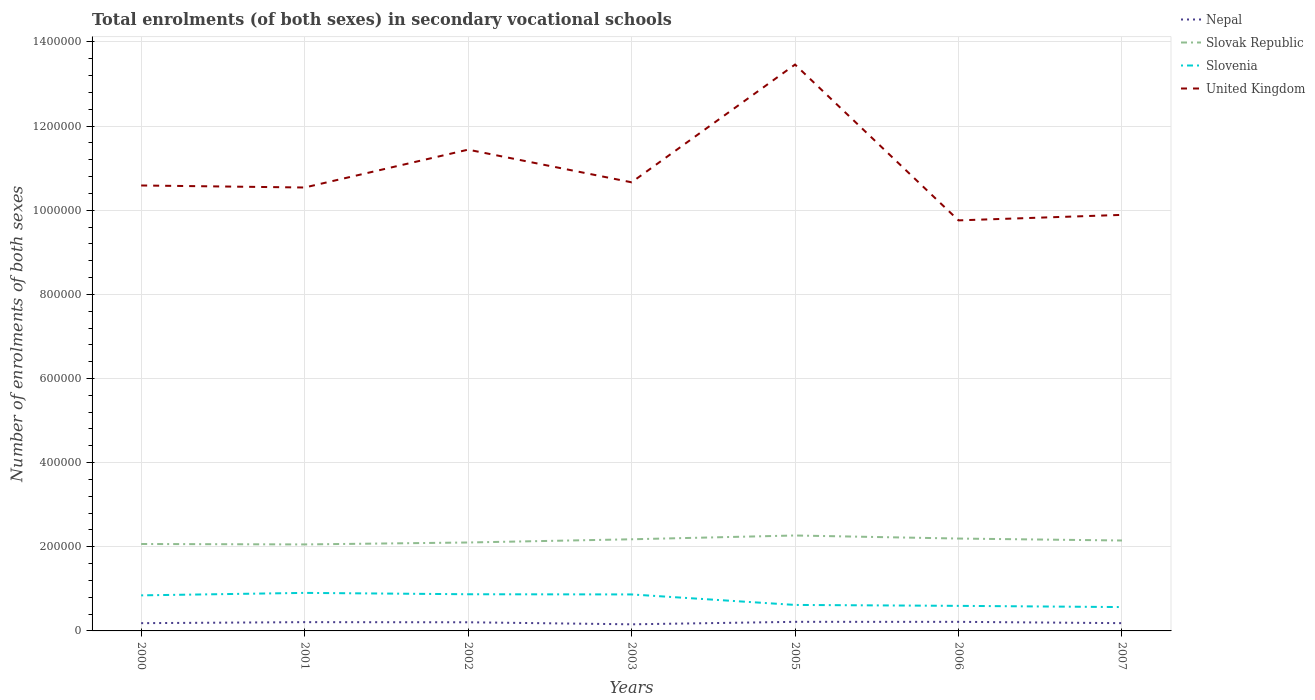How many different coloured lines are there?
Provide a succinct answer. 4. Across all years, what is the maximum number of enrolments in secondary schools in Slovenia?
Provide a short and direct response. 5.67e+04. In which year was the number of enrolments in secondary schools in Slovenia maximum?
Give a very brief answer. 2007. What is the total number of enrolments in secondary schools in Slovak Republic in the graph?
Offer a very short reply. -1.40e+04. What is the difference between the highest and the second highest number of enrolments in secondary schools in Slovenia?
Keep it short and to the point. 3.37e+04. What is the difference between the highest and the lowest number of enrolments in secondary schools in United Kingdom?
Your response must be concise. 2. Is the number of enrolments in secondary schools in United Kingdom strictly greater than the number of enrolments in secondary schools in Slovenia over the years?
Provide a short and direct response. No. How many lines are there?
Provide a succinct answer. 4. How many years are there in the graph?
Provide a succinct answer. 7. Does the graph contain any zero values?
Ensure brevity in your answer.  No. Does the graph contain grids?
Your response must be concise. Yes. Where does the legend appear in the graph?
Give a very brief answer. Top right. How many legend labels are there?
Offer a terse response. 4. What is the title of the graph?
Your answer should be very brief. Total enrolments (of both sexes) in secondary vocational schools. What is the label or title of the Y-axis?
Your answer should be compact. Number of enrolments of both sexes. What is the Number of enrolments of both sexes of Nepal in 2000?
Ensure brevity in your answer.  1.85e+04. What is the Number of enrolments of both sexes in Slovak Republic in 2000?
Give a very brief answer. 2.07e+05. What is the Number of enrolments of both sexes of Slovenia in 2000?
Offer a terse response. 8.45e+04. What is the Number of enrolments of both sexes of United Kingdom in 2000?
Your response must be concise. 1.06e+06. What is the Number of enrolments of both sexes in Nepal in 2001?
Make the answer very short. 2.09e+04. What is the Number of enrolments of both sexes of Slovak Republic in 2001?
Provide a short and direct response. 2.06e+05. What is the Number of enrolments of both sexes of Slovenia in 2001?
Your answer should be very brief. 9.04e+04. What is the Number of enrolments of both sexes in United Kingdom in 2001?
Your answer should be very brief. 1.05e+06. What is the Number of enrolments of both sexes of Nepal in 2002?
Provide a short and direct response. 2.05e+04. What is the Number of enrolments of both sexes in Slovak Republic in 2002?
Your answer should be very brief. 2.10e+05. What is the Number of enrolments of both sexes in Slovenia in 2002?
Your answer should be compact. 8.72e+04. What is the Number of enrolments of both sexes in United Kingdom in 2002?
Offer a very short reply. 1.14e+06. What is the Number of enrolments of both sexes in Nepal in 2003?
Keep it short and to the point. 1.57e+04. What is the Number of enrolments of both sexes of Slovak Republic in 2003?
Ensure brevity in your answer.  2.18e+05. What is the Number of enrolments of both sexes in Slovenia in 2003?
Your answer should be compact. 8.67e+04. What is the Number of enrolments of both sexes of United Kingdom in 2003?
Make the answer very short. 1.07e+06. What is the Number of enrolments of both sexes of Nepal in 2005?
Offer a terse response. 2.16e+04. What is the Number of enrolments of both sexes in Slovak Republic in 2005?
Provide a short and direct response. 2.27e+05. What is the Number of enrolments of both sexes of Slovenia in 2005?
Offer a very short reply. 6.18e+04. What is the Number of enrolments of both sexes in United Kingdom in 2005?
Your response must be concise. 1.35e+06. What is the Number of enrolments of both sexes of Nepal in 2006?
Your answer should be compact. 2.16e+04. What is the Number of enrolments of both sexes of Slovak Republic in 2006?
Make the answer very short. 2.20e+05. What is the Number of enrolments of both sexes in Slovenia in 2006?
Give a very brief answer. 5.96e+04. What is the Number of enrolments of both sexes in United Kingdom in 2006?
Your answer should be very brief. 9.76e+05. What is the Number of enrolments of both sexes of Nepal in 2007?
Ensure brevity in your answer.  1.85e+04. What is the Number of enrolments of both sexes in Slovak Republic in 2007?
Offer a terse response. 2.15e+05. What is the Number of enrolments of both sexes of Slovenia in 2007?
Provide a succinct answer. 5.67e+04. What is the Number of enrolments of both sexes in United Kingdom in 2007?
Provide a succinct answer. 9.89e+05. Across all years, what is the maximum Number of enrolments of both sexes in Nepal?
Give a very brief answer. 2.16e+04. Across all years, what is the maximum Number of enrolments of both sexes in Slovak Republic?
Your response must be concise. 2.27e+05. Across all years, what is the maximum Number of enrolments of both sexes in Slovenia?
Provide a short and direct response. 9.04e+04. Across all years, what is the maximum Number of enrolments of both sexes of United Kingdom?
Keep it short and to the point. 1.35e+06. Across all years, what is the minimum Number of enrolments of both sexes of Nepal?
Provide a short and direct response. 1.57e+04. Across all years, what is the minimum Number of enrolments of both sexes of Slovak Republic?
Give a very brief answer. 2.06e+05. Across all years, what is the minimum Number of enrolments of both sexes of Slovenia?
Offer a very short reply. 5.67e+04. Across all years, what is the minimum Number of enrolments of both sexes in United Kingdom?
Your response must be concise. 9.76e+05. What is the total Number of enrolments of both sexes of Nepal in the graph?
Offer a very short reply. 1.37e+05. What is the total Number of enrolments of both sexes of Slovak Republic in the graph?
Provide a short and direct response. 1.50e+06. What is the total Number of enrolments of both sexes in Slovenia in the graph?
Your answer should be compact. 5.27e+05. What is the total Number of enrolments of both sexes in United Kingdom in the graph?
Ensure brevity in your answer.  7.63e+06. What is the difference between the Number of enrolments of both sexes of Nepal in 2000 and that in 2001?
Your response must be concise. -2393. What is the difference between the Number of enrolments of both sexes of Slovak Republic in 2000 and that in 2001?
Your response must be concise. 1019. What is the difference between the Number of enrolments of both sexes in Slovenia in 2000 and that in 2001?
Ensure brevity in your answer.  -5874. What is the difference between the Number of enrolments of both sexes in United Kingdom in 2000 and that in 2001?
Offer a terse response. 4828. What is the difference between the Number of enrolments of both sexes of Nepal in 2000 and that in 2002?
Your response must be concise. -2083. What is the difference between the Number of enrolments of both sexes of Slovak Republic in 2000 and that in 2002?
Your answer should be compact. -3580. What is the difference between the Number of enrolments of both sexes of Slovenia in 2000 and that in 2002?
Your answer should be compact. -2651. What is the difference between the Number of enrolments of both sexes of United Kingdom in 2000 and that in 2002?
Provide a short and direct response. -8.52e+04. What is the difference between the Number of enrolments of both sexes of Nepal in 2000 and that in 2003?
Give a very brief answer. 2755. What is the difference between the Number of enrolments of both sexes of Slovak Republic in 2000 and that in 2003?
Your response must be concise. -1.12e+04. What is the difference between the Number of enrolments of both sexes in Slovenia in 2000 and that in 2003?
Offer a terse response. -2204. What is the difference between the Number of enrolments of both sexes of United Kingdom in 2000 and that in 2003?
Give a very brief answer. -7557. What is the difference between the Number of enrolments of both sexes of Nepal in 2000 and that in 2005?
Ensure brevity in your answer.  -3139. What is the difference between the Number of enrolments of both sexes of Slovak Republic in 2000 and that in 2005?
Give a very brief answer. -2.02e+04. What is the difference between the Number of enrolments of both sexes in Slovenia in 2000 and that in 2005?
Offer a terse response. 2.27e+04. What is the difference between the Number of enrolments of both sexes in United Kingdom in 2000 and that in 2005?
Give a very brief answer. -2.87e+05. What is the difference between the Number of enrolments of both sexes of Nepal in 2000 and that in 2006?
Offer a very short reply. -3125. What is the difference between the Number of enrolments of both sexes in Slovak Republic in 2000 and that in 2006?
Your response must be concise. -1.29e+04. What is the difference between the Number of enrolments of both sexes in Slovenia in 2000 and that in 2006?
Make the answer very short. 2.49e+04. What is the difference between the Number of enrolments of both sexes of United Kingdom in 2000 and that in 2006?
Give a very brief answer. 8.30e+04. What is the difference between the Number of enrolments of both sexes in Slovak Republic in 2000 and that in 2007?
Your response must be concise. -8316. What is the difference between the Number of enrolments of both sexes in Slovenia in 2000 and that in 2007?
Your answer should be very brief. 2.78e+04. What is the difference between the Number of enrolments of both sexes of United Kingdom in 2000 and that in 2007?
Offer a very short reply. 6.99e+04. What is the difference between the Number of enrolments of both sexes of Nepal in 2001 and that in 2002?
Your response must be concise. 310. What is the difference between the Number of enrolments of both sexes of Slovak Republic in 2001 and that in 2002?
Offer a very short reply. -4599. What is the difference between the Number of enrolments of both sexes in Slovenia in 2001 and that in 2002?
Give a very brief answer. 3223. What is the difference between the Number of enrolments of both sexes in United Kingdom in 2001 and that in 2002?
Make the answer very short. -9.00e+04. What is the difference between the Number of enrolments of both sexes of Nepal in 2001 and that in 2003?
Provide a succinct answer. 5148. What is the difference between the Number of enrolments of both sexes in Slovak Republic in 2001 and that in 2003?
Your answer should be very brief. -1.22e+04. What is the difference between the Number of enrolments of both sexes in Slovenia in 2001 and that in 2003?
Offer a very short reply. 3670. What is the difference between the Number of enrolments of both sexes in United Kingdom in 2001 and that in 2003?
Provide a succinct answer. -1.24e+04. What is the difference between the Number of enrolments of both sexes in Nepal in 2001 and that in 2005?
Offer a terse response. -746. What is the difference between the Number of enrolments of both sexes of Slovak Republic in 2001 and that in 2005?
Your response must be concise. -2.12e+04. What is the difference between the Number of enrolments of both sexes in Slovenia in 2001 and that in 2005?
Keep it short and to the point. 2.86e+04. What is the difference between the Number of enrolments of both sexes in United Kingdom in 2001 and that in 2005?
Keep it short and to the point. -2.92e+05. What is the difference between the Number of enrolments of both sexes of Nepal in 2001 and that in 2006?
Offer a very short reply. -732. What is the difference between the Number of enrolments of both sexes of Slovak Republic in 2001 and that in 2006?
Keep it short and to the point. -1.40e+04. What is the difference between the Number of enrolments of both sexes in Slovenia in 2001 and that in 2006?
Offer a very short reply. 3.08e+04. What is the difference between the Number of enrolments of both sexes of United Kingdom in 2001 and that in 2006?
Your answer should be compact. 7.81e+04. What is the difference between the Number of enrolments of both sexes in Nepal in 2001 and that in 2007?
Provide a succinct answer. 2387. What is the difference between the Number of enrolments of both sexes in Slovak Republic in 2001 and that in 2007?
Provide a succinct answer. -9335. What is the difference between the Number of enrolments of both sexes of Slovenia in 2001 and that in 2007?
Your answer should be compact. 3.37e+04. What is the difference between the Number of enrolments of both sexes in United Kingdom in 2001 and that in 2007?
Offer a very short reply. 6.51e+04. What is the difference between the Number of enrolments of both sexes of Nepal in 2002 and that in 2003?
Offer a very short reply. 4838. What is the difference between the Number of enrolments of both sexes in Slovak Republic in 2002 and that in 2003?
Your response must be concise. -7640. What is the difference between the Number of enrolments of both sexes of Slovenia in 2002 and that in 2003?
Give a very brief answer. 447. What is the difference between the Number of enrolments of both sexes in United Kingdom in 2002 and that in 2003?
Provide a short and direct response. 7.76e+04. What is the difference between the Number of enrolments of both sexes of Nepal in 2002 and that in 2005?
Provide a short and direct response. -1056. What is the difference between the Number of enrolments of both sexes in Slovak Republic in 2002 and that in 2005?
Provide a succinct answer. -1.66e+04. What is the difference between the Number of enrolments of both sexes in Slovenia in 2002 and that in 2005?
Ensure brevity in your answer.  2.54e+04. What is the difference between the Number of enrolments of both sexes in United Kingdom in 2002 and that in 2005?
Ensure brevity in your answer.  -2.02e+05. What is the difference between the Number of enrolments of both sexes of Nepal in 2002 and that in 2006?
Your answer should be very brief. -1042. What is the difference between the Number of enrolments of both sexes in Slovak Republic in 2002 and that in 2006?
Offer a terse response. -9366. What is the difference between the Number of enrolments of both sexes in Slovenia in 2002 and that in 2006?
Offer a very short reply. 2.76e+04. What is the difference between the Number of enrolments of both sexes in United Kingdom in 2002 and that in 2006?
Keep it short and to the point. 1.68e+05. What is the difference between the Number of enrolments of both sexes in Nepal in 2002 and that in 2007?
Provide a short and direct response. 2077. What is the difference between the Number of enrolments of both sexes in Slovak Republic in 2002 and that in 2007?
Make the answer very short. -4736. What is the difference between the Number of enrolments of both sexes of Slovenia in 2002 and that in 2007?
Ensure brevity in your answer.  3.05e+04. What is the difference between the Number of enrolments of both sexes in United Kingdom in 2002 and that in 2007?
Your answer should be compact. 1.55e+05. What is the difference between the Number of enrolments of both sexes of Nepal in 2003 and that in 2005?
Keep it short and to the point. -5894. What is the difference between the Number of enrolments of both sexes in Slovak Republic in 2003 and that in 2005?
Make the answer very short. -9008. What is the difference between the Number of enrolments of both sexes of Slovenia in 2003 and that in 2005?
Give a very brief answer. 2.50e+04. What is the difference between the Number of enrolments of both sexes in United Kingdom in 2003 and that in 2005?
Offer a terse response. -2.80e+05. What is the difference between the Number of enrolments of both sexes of Nepal in 2003 and that in 2006?
Keep it short and to the point. -5880. What is the difference between the Number of enrolments of both sexes of Slovak Republic in 2003 and that in 2006?
Offer a terse response. -1726. What is the difference between the Number of enrolments of both sexes of Slovenia in 2003 and that in 2006?
Make the answer very short. 2.71e+04. What is the difference between the Number of enrolments of both sexes in United Kingdom in 2003 and that in 2006?
Your response must be concise. 9.05e+04. What is the difference between the Number of enrolments of both sexes in Nepal in 2003 and that in 2007?
Offer a very short reply. -2761. What is the difference between the Number of enrolments of both sexes of Slovak Republic in 2003 and that in 2007?
Ensure brevity in your answer.  2904. What is the difference between the Number of enrolments of both sexes in Slovenia in 2003 and that in 2007?
Give a very brief answer. 3.00e+04. What is the difference between the Number of enrolments of both sexes of United Kingdom in 2003 and that in 2007?
Provide a succinct answer. 7.75e+04. What is the difference between the Number of enrolments of both sexes in Slovak Republic in 2005 and that in 2006?
Provide a succinct answer. 7282. What is the difference between the Number of enrolments of both sexes in Slovenia in 2005 and that in 2006?
Offer a very short reply. 2196. What is the difference between the Number of enrolments of both sexes in United Kingdom in 2005 and that in 2006?
Ensure brevity in your answer.  3.70e+05. What is the difference between the Number of enrolments of both sexes of Nepal in 2005 and that in 2007?
Ensure brevity in your answer.  3133. What is the difference between the Number of enrolments of both sexes in Slovak Republic in 2005 and that in 2007?
Your answer should be very brief. 1.19e+04. What is the difference between the Number of enrolments of both sexes in Slovenia in 2005 and that in 2007?
Your answer should be compact. 5099. What is the difference between the Number of enrolments of both sexes in United Kingdom in 2005 and that in 2007?
Make the answer very short. 3.57e+05. What is the difference between the Number of enrolments of both sexes in Nepal in 2006 and that in 2007?
Make the answer very short. 3119. What is the difference between the Number of enrolments of both sexes in Slovak Republic in 2006 and that in 2007?
Your answer should be compact. 4630. What is the difference between the Number of enrolments of both sexes in Slovenia in 2006 and that in 2007?
Your answer should be very brief. 2903. What is the difference between the Number of enrolments of both sexes in United Kingdom in 2006 and that in 2007?
Offer a terse response. -1.30e+04. What is the difference between the Number of enrolments of both sexes in Nepal in 2000 and the Number of enrolments of both sexes in Slovak Republic in 2001?
Offer a terse response. -1.87e+05. What is the difference between the Number of enrolments of both sexes in Nepal in 2000 and the Number of enrolments of both sexes in Slovenia in 2001?
Make the answer very short. -7.19e+04. What is the difference between the Number of enrolments of both sexes in Nepal in 2000 and the Number of enrolments of both sexes in United Kingdom in 2001?
Offer a very short reply. -1.04e+06. What is the difference between the Number of enrolments of both sexes in Slovak Republic in 2000 and the Number of enrolments of both sexes in Slovenia in 2001?
Your answer should be compact. 1.16e+05. What is the difference between the Number of enrolments of both sexes in Slovak Republic in 2000 and the Number of enrolments of both sexes in United Kingdom in 2001?
Offer a terse response. -8.47e+05. What is the difference between the Number of enrolments of both sexes of Slovenia in 2000 and the Number of enrolments of both sexes of United Kingdom in 2001?
Make the answer very short. -9.70e+05. What is the difference between the Number of enrolments of both sexes of Nepal in 2000 and the Number of enrolments of both sexes of Slovak Republic in 2002?
Provide a succinct answer. -1.92e+05. What is the difference between the Number of enrolments of both sexes in Nepal in 2000 and the Number of enrolments of both sexes in Slovenia in 2002?
Make the answer very short. -6.87e+04. What is the difference between the Number of enrolments of both sexes of Nepal in 2000 and the Number of enrolments of both sexes of United Kingdom in 2002?
Offer a terse response. -1.13e+06. What is the difference between the Number of enrolments of both sexes of Slovak Republic in 2000 and the Number of enrolments of both sexes of Slovenia in 2002?
Your response must be concise. 1.19e+05. What is the difference between the Number of enrolments of both sexes of Slovak Republic in 2000 and the Number of enrolments of both sexes of United Kingdom in 2002?
Ensure brevity in your answer.  -9.37e+05. What is the difference between the Number of enrolments of both sexes in Slovenia in 2000 and the Number of enrolments of both sexes in United Kingdom in 2002?
Provide a succinct answer. -1.06e+06. What is the difference between the Number of enrolments of both sexes of Nepal in 2000 and the Number of enrolments of both sexes of Slovak Republic in 2003?
Your answer should be very brief. -1.99e+05. What is the difference between the Number of enrolments of both sexes of Nepal in 2000 and the Number of enrolments of both sexes of Slovenia in 2003?
Your response must be concise. -6.83e+04. What is the difference between the Number of enrolments of both sexes in Nepal in 2000 and the Number of enrolments of both sexes in United Kingdom in 2003?
Your answer should be very brief. -1.05e+06. What is the difference between the Number of enrolments of both sexes of Slovak Republic in 2000 and the Number of enrolments of both sexes of Slovenia in 2003?
Your answer should be very brief. 1.20e+05. What is the difference between the Number of enrolments of both sexes in Slovak Republic in 2000 and the Number of enrolments of both sexes in United Kingdom in 2003?
Your response must be concise. -8.60e+05. What is the difference between the Number of enrolments of both sexes of Slovenia in 2000 and the Number of enrolments of both sexes of United Kingdom in 2003?
Your answer should be compact. -9.82e+05. What is the difference between the Number of enrolments of both sexes of Nepal in 2000 and the Number of enrolments of both sexes of Slovak Republic in 2005?
Your answer should be compact. -2.08e+05. What is the difference between the Number of enrolments of both sexes of Nepal in 2000 and the Number of enrolments of both sexes of Slovenia in 2005?
Offer a very short reply. -4.33e+04. What is the difference between the Number of enrolments of both sexes in Nepal in 2000 and the Number of enrolments of both sexes in United Kingdom in 2005?
Your answer should be very brief. -1.33e+06. What is the difference between the Number of enrolments of both sexes in Slovak Republic in 2000 and the Number of enrolments of both sexes in Slovenia in 2005?
Provide a short and direct response. 1.45e+05. What is the difference between the Number of enrolments of both sexes in Slovak Republic in 2000 and the Number of enrolments of both sexes in United Kingdom in 2005?
Your answer should be very brief. -1.14e+06. What is the difference between the Number of enrolments of both sexes of Slovenia in 2000 and the Number of enrolments of both sexes of United Kingdom in 2005?
Your answer should be very brief. -1.26e+06. What is the difference between the Number of enrolments of both sexes in Nepal in 2000 and the Number of enrolments of both sexes in Slovak Republic in 2006?
Offer a very short reply. -2.01e+05. What is the difference between the Number of enrolments of both sexes in Nepal in 2000 and the Number of enrolments of both sexes in Slovenia in 2006?
Offer a terse response. -4.11e+04. What is the difference between the Number of enrolments of both sexes in Nepal in 2000 and the Number of enrolments of both sexes in United Kingdom in 2006?
Your response must be concise. -9.57e+05. What is the difference between the Number of enrolments of both sexes in Slovak Republic in 2000 and the Number of enrolments of both sexes in Slovenia in 2006?
Offer a very short reply. 1.47e+05. What is the difference between the Number of enrolments of both sexes of Slovak Republic in 2000 and the Number of enrolments of both sexes of United Kingdom in 2006?
Offer a very short reply. -7.69e+05. What is the difference between the Number of enrolments of both sexes in Slovenia in 2000 and the Number of enrolments of both sexes in United Kingdom in 2006?
Make the answer very short. -8.91e+05. What is the difference between the Number of enrolments of both sexes of Nepal in 2000 and the Number of enrolments of both sexes of Slovak Republic in 2007?
Give a very brief answer. -1.96e+05. What is the difference between the Number of enrolments of both sexes of Nepal in 2000 and the Number of enrolments of both sexes of Slovenia in 2007?
Keep it short and to the point. -3.82e+04. What is the difference between the Number of enrolments of both sexes of Nepal in 2000 and the Number of enrolments of both sexes of United Kingdom in 2007?
Keep it short and to the point. -9.71e+05. What is the difference between the Number of enrolments of both sexes in Slovak Republic in 2000 and the Number of enrolments of both sexes in Slovenia in 2007?
Give a very brief answer. 1.50e+05. What is the difference between the Number of enrolments of both sexes in Slovak Republic in 2000 and the Number of enrolments of both sexes in United Kingdom in 2007?
Provide a short and direct response. -7.82e+05. What is the difference between the Number of enrolments of both sexes of Slovenia in 2000 and the Number of enrolments of both sexes of United Kingdom in 2007?
Offer a terse response. -9.04e+05. What is the difference between the Number of enrolments of both sexes of Nepal in 2001 and the Number of enrolments of both sexes of Slovak Republic in 2002?
Provide a short and direct response. -1.89e+05. What is the difference between the Number of enrolments of both sexes in Nepal in 2001 and the Number of enrolments of both sexes in Slovenia in 2002?
Give a very brief answer. -6.63e+04. What is the difference between the Number of enrolments of both sexes in Nepal in 2001 and the Number of enrolments of both sexes in United Kingdom in 2002?
Give a very brief answer. -1.12e+06. What is the difference between the Number of enrolments of both sexes in Slovak Republic in 2001 and the Number of enrolments of both sexes in Slovenia in 2002?
Provide a succinct answer. 1.18e+05. What is the difference between the Number of enrolments of both sexes in Slovak Republic in 2001 and the Number of enrolments of both sexes in United Kingdom in 2002?
Ensure brevity in your answer.  -9.38e+05. What is the difference between the Number of enrolments of both sexes of Slovenia in 2001 and the Number of enrolments of both sexes of United Kingdom in 2002?
Give a very brief answer. -1.05e+06. What is the difference between the Number of enrolments of both sexes in Nepal in 2001 and the Number of enrolments of both sexes in Slovak Republic in 2003?
Offer a terse response. -1.97e+05. What is the difference between the Number of enrolments of both sexes of Nepal in 2001 and the Number of enrolments of both sexes of Slovenia in 2003?
Your answer should be compact. -6.59e+04. What is the difference between the Number of enrolments of both sexes of Nepal in 2001 and the Number of enrolments of both sexes of United Kingdom in 2003?
Give a very brief answer. -1.05e+06. What is the difference between the Number of enrolments of both sexes of Slovak Republic in 2001 and the Number of enrolments of both sexes of Slovenia in 2003?
Provide a succinct answer. 1.19e+05. What is the difference between the Number of enrolments of both sexes in Slovak Republic in 2001 and the Number of enrolments of both sexes in United Kingdom in 2003?
Offer a very short reply. -8.61e+05. What is the difference between the Number of enrolments of both sexes in Slovenia in 2001 and the Number of enrolments of both sexes in United Kingdom in 2003?
Your answer should be compact. -9.76e+05. What is the difference between the Number of enrolments of both sexes in Nepal in 2001 and the Number of enrolments of both sexes in Slovak Republic in 2005?
Keep it short and to the point. -2.06e+05. What is the difference between the Number of enrolments of both sexes in Nepal in 2001 and the Number of enrolments of both sexes in Slovenia in 2005?
Offer a terse response. -4.09e+04. What is the difference between the Number of enrolments of both sexes of Nepal in 2001 and the Number of enrolments of both sexes of United Kingdom in 2005?
Offer a very short reply. -1.33e+06. What is the difference between the Number of enrolments of both sexes in Slovak Republic in 2001 and the Number of enrolments of both sexes in Slovenia in 2005?
Your response must be concise. 1.44e+05. What is the difference between the Number of enrolments of both sexes in Slovak Republic in 2001 and the Number of enrolments of both sexes in United Kingdom in 2005?
Your answer should be very brief. -1.14e+06. What is the difference between the Number of enrolments of both sexes of Slovenia in 2001 and the Number of enrolments of both sexes of United Kingdom in 2005?
Make the answer very short. -1.26e+06. What is the difference between the Number of enrolments of both sexes in Nepal in 2001 and the Number of enrolments of both sexes in Slovak Republic in 2006?
Your response must be concise. -1.99e+05. What is the difference between the Number of enrolments of both sexes in Nepal in 2001 and the Number of enrolments of both sexes in Slovenia in 2006?
Your answer should be compact. -3.87e+04. What is the difference between the Number of enrolments of both sexes in Nepal in 2001 and the Number of enrolments of both sexes in United Kingdom in 2006?
Make the answer very short. -9.55e+05. What is the difference between the Number of enrolments of both sexes of Slovak Republic in 2001 and the Number of enrolments of both sexes of Slovenia in 2006?
Your response must be concise. 1.46e+05. What is the difference between the Number of enrolments of both sexes in Slovak Republic in 2001 and the Number of enrolments of both sexes in United Kingdom in 2006?
Offer a terse response. -7.70e+05. What is the difference between the Number of enrolments of both sexes in Slovenia in 2001 and the Number of enrolments of both sexes in United Kingdom in 2006?
Give a very brief answer. -8.86e+05. What is the difference between the Number of enrolments of both sexes of Nepal in 2001 and the Number of enrolments of both sexes of Slovak Republic in 2007?
Your answer should be compact. -1.94e+05. What is the difference between the Number of enrolments of both sexes in Nepal in 2001 and the Number of enrolments of both sexes in Slovenia in 2007?
Provide a short and direct response. -3.58e+04. What is the difference between the Number of enrolments of both sexes of Nepal in 2001 and the Number of enrolments of both sexes of United Kingdom in 2007?
Offer a terse response. -9.68e+05. What is the difference between the Number of enrolments of both sexes of Slovak Republic in 2001 and the Number of enrolments of both sexes of Slovenia in 2007?
Provide a short and direct response. 1.49e+05. What is the difference between the Number of enrolments of both sexes of Slovak Republic in 2001 and the Number of enrolments of both sexes of United Kingdom in 2007?
Keep it short and to the point. -7.83e+05. What is the difference between the Number of enrolments of both sexes of Slovenia in 2001 and the Number of enrolments of both sexes of United Kingdom in 2007?
Make the answer very short. -8.99e+05. What is the difference between the Number of enrolments of both sexes in Nepal in 2002 and the Number of enrolments of both sexes in Slovak Republic in 2003?
Offer a terse response. -1.97e+05. What is the difference between the Number of enrolments of both sexes in Nepal in 2002 and the Number of enrolments of both sexes in Slovenia in 2003?
Offer a very short reply. -6.62e+04. What is the difference between the Number of enrolments of both sexes in Nepal in 2002 and the Number of enrolments of both sexes in United Kingdom in 2003?
Offer a terse response. -1.05e+06. What is the difference between the Number of enrolments of both sexes of Slovak Republic in 2002 and the Number of enrolments of both sexes of Slovenia in 2003?
Give a very brief answer. 1.23e+05. What is the difference between the Number of enrolments of both sexes of Slovak Republic in 2002 and the Number of enrolments of both sexes of United Kingdom in 2003?
Provide a succinct answer. -8.56e+05. What is the difference between the Number of enrolments of both sexes of Slovenia in 2002 and the Number of enrolments of both sexes of United Kingdom in 2003?
Your answer should be very brief. -9.79e+05. What is the difference between the Number of enrolments of both sexes in Nepal in 2002 and the Number of enrolments of both sexes in Slovak Republic in 2005?
Keep it short and to the point. -2.06e+05. What is the difference between the Number of enrolments of both sexes of Nepal in 2002 and the Number of enrolments of both sexes of Slovenia in 2005?
Your answer should be very brief. -4.12e+04. What is the difference between the Number of enrolments of both sexes in Nepal in 2002 and the Number of enrolments of both sexes in United Kingdom in 2005?
Make the answer very short. -1.33e+06. What is the difference between the Number of enrolments of both sexes of Slovak Republic in 2002 and the Number of enrolments of both sexes of Slovenia in 2005?
Provide a succinct answer. 1.48e+05. What is the difference between the Number of enrolments of both sexes of Slovak Republic in 2002 and the Number of enrolments of both sexes of United Kingdom in 2005?
Keep it short and to the point. -1.14e+06. What is the difference between the Number of enrolments of both sexes of Slovenia in 2002 and the Number of enrolments of both sexes of United Kingdom in 2005?
Your response must be concise. -1.26e+06. What is the difference between the Number of enrolments of both sexes of Nepal in 2002 and the Number of enrolments of both sexes of Slovak Republic in 2006?
Provide a succinct answer. -1.99e+05. What is the difference between the Number of enrolments of both sexes of Nepal in 2002 and the Number of enrolments of both sexes of Slovenia in 2006?
Give a very brief answer. -3.90e+04. What is the difference between the Number of enrolments of both sexes in Nepal in 2002 and the Number of enrolments of both sexes in United Kingdom in 2006?
Keep it short and to the point. -9.55e+05. What is the difference between the Number of enrolments of both sexes in Slovak Republic in 2002 and the Number of enrolments of both sexes in Slovenia in 2006?
Keep it short and to the point. 1.51e+05. What is the difference between the Number of enrolments of both sexes of Slovak Republic in 2002 and the Number of enrolments of both sexes of United Kingdom in 2006?
Give a very brief answer. -7.66e+05. What is the difference between the Number of enrolments of both sexes in Slovenia in 2002 and the Number of enrolments of both sexes in United Kingdom in 2006?
Provide a short and direct response. -8.89e+05. What is the difference between the Number of enrolments of both sexes of Nepal in 2002 and the Number of enrolments of both sexes of Slovak Republic in 2007?
Your response must be concise. -1.94e+05. What is the difference between the Number of enrolments of both sexes in Nepal in 2002 and the Number of enrolments of both sexes in Slovenia in 2007?
Ensure brevity in your answer.  -3.61e+04. What is the difference between the Number of enrolments of both sexes of Nepal in 2002 and the Number of enrolments of both sexes of United Kingdom in 2007?
Your response must be concise. -9.68e+05. What is the difference between the Number of enrolments of both sexes in Slovak Republic in 2002 and the Number of enrolments of both sexes in Slovenia in 2007?
Offer a terse response. 1.54e+05. What is the difference between the Number of enrolments of both sexes of Slovak Republic in 2002 and the Number of enrolments of both sexes of United Kingdom in 2007?
Ensure brevity in your answer.  -7.79e+05. What is the difference between the Number of enrolments of both sexes of Slovenia in 2002 and the Number of enrolments of both sexes of United Kingdom in 2007?
Your answer should be compact. -9.02e+05. What is the difference between the Number of enrolments of both sexes in Nepal in 2003 and the Number of enrolments of both sexes in Slovak Republic in 2005?
Offer a very short reply. -2.11e+05. What is the difference between the Number of enrolments of both sexes of Nepal in 2003 and the Number of enrolments of both sexes of Slovenia in 2005?
Offer a very short reply. -4.61e+04. What is the difference between the Number of enrolments of both sexes in Nepal in 2003 and the Number of enrolments of both sexes in United Kingdom in 2005?
Give a very brief answer. -1.33e+06. What is the difference between the Number of enrolments of both sexes in Slovak Republic in 2003 and the Number of enrolments of both sexes in Slovenia in 2005?
Make the answer very short. 1.56e+05. What is the difference between the Number of enrolments of both sexes in Slovak Republic in 2003 and the Number of enrolments of both sexes in United Kingdom in 2005?
Your response must be concise. -1.13e+06. What is the difference between the Number of enrolments of both sexes of Slovenia in 2003 and the Number of enrolments of both sexes of United Kingdom in 2005?
Your answer should be very brief. -1.26e+06. What is the difference between the Number of enrolments of both sexes in Nepal in 2003 and the Number of enrolments of both sexes in Slovak Republic in 2006?
Your response must be concise. -2.04e+05. What is the difference between the Number of enrolments of both sexes in Nepal in 2003 and the Number of enrolments of both sexes in Slovenia in 2006?
Give a very brief answer. -4.39e+04. What is the difference between the Number of enrolments of both sexes in Nepal in 2003 and the Number of enrolments of both sexes in United Kingdom in 2006?
Make the answer very short. -9.60e+05. What is the difference between the Number of enrolments of both sexes of Slovak Republic in 2003 and the Number of enrolments of both sexes of Slovenia in 2006?
Offer a very short reply. 1.58e+05. What is the difference between the Number of enrolments of both sexes in Slovak Republic in 2003 and the Number of enrolments of both sexes in United Kingdom in 2006?
Your response must be concise. -7.58e+05. What is the difference between the Number of enrolments of both sexes in Slovenia in 2003 and the Number of enrolments of both sexes in United Kingdom in 2006?
Your answer should be compact. -8.89e+05. What is the difference between the Number of enrolments of both sexes in Nepal in 2003 and the Number of enrolments of both sexes in Slovak Republic in 2007?
Your answer should be compact. -1.99e+05. What is the difference between the Number of enrolments of both sexes of Nepal in 2003 and the Number of enrolments of both sexes of Slovenia in 2007?
Your answer should be very brief. -4.10e+04. What is the difference between the Number of enrolments of both sexes in Nepal in 2003 and the Number of enrolments of both sexes in United Kingdom in 2007?
Your answer should be compact. -9.73e+05. What is the difference between the Number of enrolments of both sexes in Slovak Republic in 2003 and the Number of enrolments of both sexes in Slovenia in 2007?
Ensure brevity in your answer.  1.61e+05. What is the difference between the Number of enrolments of both sexes of Slovak Republic in 2003 and the Number of enrolments of both sexes of United Kingdom in 2007?
Your answer should be compact. -7.71e+05. What is the difference between the Number of enrolments of both sexes in Slovenia in 2003 and the Number of enrolments of both sexes in United Kingdom in 2007?
Keep it short and to the point. -9.02e+05. What is the difference between the Number of enrolments of both sexes of Nepal in 2005 and the Number of enrolments of both sexes of Slovak Republic in 2006?
Provide a succinct answer. -1.98e+05. What is the difference between the Number of enrolments of both sexes of Nepal in 2005 and the Number of enrolments of both sexes of Slovenia in 2006?
Offer a very short reply. -3.80e+04. What is the difference between the Number of enrolments of both sexes in Nepal in 2005 and the Number of enrolments of both sexes in United Kingdom in 2006?
Give a very brief answer. -9.54e+05. What is the difference between the Number of enrolments of both sexes of Slovak Republic in 2005 and the Number of enrolments of both sexes of Slovenia in 2006?
Offer a terse response. 1.67e+05. What is the difference between the Number of enrolments of both sexes of Slovak Republic in 2005 and the Number of enrolments of both sexes of United Kingdom in 2006?
Provide a succinct answer. -7.49e+05. What is the difference between the Number of enrolments of both sexes of Slovenia in 2005 and the Number of enrolments of both sexes of United Kingdom in 2006?
Your answer should be compact. -9.14e+05. What is the difference between the Number of enrolments of both sexes in Nepal in 2005 and the Number of enrolments of both sexes in Slovak Republic in 2007?
Give a very brief answer. -1.93e+05. What is the difference between the Number of enrolments of both sexes of Nepal in 2005 and the Number of enrolments of both sexes of Slovenia in 2007?
Give a very brief answer. -3.51e+04. What is the difference between the Number of enrolments of both sexes of Nepal in 2005 and the Number of enrolments of both sexes of United Kingdom in 2007?
Offer a terse response. -9.67e+05. What is the difference between the Number of enrolments of both sexes in Slovak Republic in 2005 and the Number of enrolments of both sexes in Slovenia in 2007?
Ensure brevity in your answer.  1.70e+05. What is the difference between the Number of enrolments of both sexes in Slovak Republic in 2005 and the Number of enrolments of both sexes in United Kingdom in 2007?
Provide a short and direct response. -7.62e+05. What is the difference between the Number of enrolments of both sexes of Slovenia in 2005 and the Number of enrolments of both sexes of United Kingdom in 2007?
Offer a very short reply. -9.27e+05. What is the difference between the Number of enrolments of both sexes in Nepal in 2006 and the Number of enrolments of both sexes in Slovak Republic in 2007?
Your answer should be compact. -1.93e+05. What is the difference between the Number of enrolments of both sexes of Nepal in 2006 and the Number of enrolments of both sexes of Slovenia in 2007?
Your answer should be very brief. -3.51e+04. What is the difference between the Number of enrolments of both sexes in Nepal in 2006 and the Number of enrolments of both sexes in United Kingdom in 2007?
Offer a terse response. -9.67e+05. What is the difference between the Number of enrolments of both sexes of Slovak Republic in 2006 and the Number of enrolments of both sexes of Slovenia in 2007?
Give a very brief answer. 1.63e+05. What is the difference between the Number of enrolments of both sexes in Slovak Republic in 2006 and the Number of enrolments of both sexes in United Kingdom in 2007?
Your answer should be compact. -7.69e+05. What is the difference between the Number of enrolments of both sexes in Slovenia in 2006 and the Number of enrolments of both sexes in United Kingdom in 2007?
Your answer should be very brief. -9.29e+05. What is the average Number of enrolments of both sexes in Nepal per year?
Provide a succinct answer. 1.96e+04. What is the average Number of enrolments of both sexes in Slovak Republic per year?
Offer a terse response. 2.15e+05. What is the average Number of enrolments of both sexes of Slovenia per year?
Give a very brief answer. 7.53e+04. What is the average Number of enrolments of both sexes of United Kingdom per year?
Your answer should be compact. 1.09e+06. In the year 2000, what is the difference between the Number of enrolments of both sexes in Nepal and Number of enrolments of both sexes in Slovak Republic?
Keep it short and to the point. -1.88e+05. In the year 2000, what is the difference between the Number of enrolments of both sexes of Nepal and Number of enrolments of both sexes of Slovenia?
Ensure brevity in your answer.  -6.61e+04. In the year 2000, what is the difference between the Number of enrolments of both sexes of Nepal and Number of enrolments of both sexes of United Kingdom?
Make the answer very short. -1.04e+06. In the year 2000, what is the difference between the Number of enrolments of both sexes of Slovak Republic and Number of enrolments of both sexes of Slovenia?
Ensure brevity in your answer.  1.22e+05. In the year 2000, what is the difference between the Number of enrolments of both sexes of Slovak Republic and Number of enrolments of both sexes of United Kingdom?
Keep it short and to the point. -8.52e+05. In the year 2000, what is the difference between the Number of enrolments of both sexes of Slovenia and Number of enrolments of both sexes of United Kingdom?
Ensure brevity in your answer.  -9.74e+05. In the year 2001, what is the difference between the Number of enrolments of both sexes in Nepal and Number of enrolments of both sexes in Slovak Republic?
Your answer should be very brief. -1.85e+05. In the year 2001, what is the difference between the Number of enrolments of both sexes of Nepal and Number of enrolments of both sexes of Slovenia?
Offer a very short reply. -6.96e+04. In the year 2001, what is the difference between the Number of enrolments of both sexes of Nepal and Number of enrolments of both sexes of United Kingdom?
Your answer should be very brief. -1.03e+06. In the year 2001, what is the difference between the Number of enrolments of both sexes in Slovak Republic and Number of enrolments of both sexes in Slovenia?
Ensure brevity in your answer.  1.15e+05. In the year 2001, what is the difference between the Number of enrolments of both sexes in Slovak Republic and Number of enrolments of both sexes in United Kingdom?
Give a very brief answer. -8.48e+05. In the year 2001, what is the difference between the Number of enrolments of both sexes of Slovenia and Number of enrolments of both sexes of United Kingdom?
Offer a very short reply. -9.64e+05. In the year 2002, what is the difference between the Number of enrolments of both sexes in Nepal and Number of enrolments of both sexes in Slovak Republic?
Provide a succinct answer. -1.90e+05. In the year 2002, what is the difference between the Number of enrolments of both sexes in Nepal and Number of enrolments of both sexes in Slovenia?
Provide a succinct answer. -6.66e+04. In the year 2002, what is the difference between the Number of enrolments of both sexes of Nepal and Number of enrolments of both sexes of United Kingdom?
Provide a short and direct response. -1.12e+06. In the year 2002, what is the difference between the Number of enrolments of both sexes in Slovak Republic and Number of enrolments of both sexes in Slovenia?
Offer a very short reply. 1.23e+05. In the year 2002, what is the difference between the Number of enrolments of both sexes in Slovak Republic and Number of enrolments of both sexes in United Kingdom?
Keep it short and to the point. -9.34e+05. In the year 2002, what is the difference between the Number of enrolments of both sexes of Slovenia and Number of enrolments of both sexes of United Kingdom?
Offer a terse response. -1.06e+06. In the year 2003, what is the difference between the Number of enrolments of both sexes in Nepal and Number of enrolments of both sexes in Slovak Republic?
Make the answer very short. -2.02e+05. In the year 2003, what is the difference between the Number of enrolments of both sexes in Nepal and Number of enrolments of both sexes in Slovenia?
Make the answer very short. -7.10e+04. In the year 2003, what is the difference between the Number of enrolments of both sexes in Nepal and Number of enrolments of both sexes in United Kingdom?
Ensure brevity in your answer.  -1.05e+06. In the year 2003, what is the difference between the Number of enrolments of both sexes in Slovak Republic and Number of enrolments of both sexes in Slovenia?
Your response must be concise. 1.31e+05. In the year 2003, what is the difference between the Number of enrolments of both sexes of Slovak Republic and Number of enrolments of both sexes of United Kingdom?
Your answer should be very brief. -8.49e+05. In the year 2003, what is the difference between the Number of enrolments of both sexes of Slovenia and Number of enrolments of both sexes of United Kingdom?
Your answer should be very brief. -9.80e+05. In the year 2005, what is the difference between the Number of enrolments of both sexes of Nepal and Number of enrolments of both sexes of Slovak Republic?
Offer a very short reply. -2.05e+05. In the year 2005, what is the difference between the Number of enrolments of both sexes of Nepal and Number of enrolments of both sexes of Slovenia?
Offer a very short reply. -4.02e+04. In the year 2005, what is the difference between the Number of enrolments of both sexes in Nepal and Number of enrolments of both sexes in United Kingdom?
Keep it short and to the point. -1.32e+06. In the year 2005, what is the difference between the Number of enrolments of both sexes in Slovak Republic and Number of enrolments of both sexes in Slovenia?
Your response must be concise. 1.65e+05. In the year 2005, what is the difference between the Number of enrolments of both sexes in Slovak Republic and Number of enrolments of both sexes in United Kingdom?
Your answer should be compact. -1.12e+06. In the year 2005, what is the difference between the Number of enrolments of both sexes in Slovenia and Number of enrolments of both sexes in United Kingdom?
Ensure brevity in your answer.  -1.28e+06. In the year 2006, what is the difference between the Number of enrolments of both sexes in Nepal and Number of enrolments of both sexes in Slovak Republic?
Make the answer very short. -1.98e+05. In the year 2006, what is the difference between the Number of enrolments of both sexes of Nepal and Number of enrolments of both sexes of Slovenia?
Offer a very short reply. -3.80e+04. In the year 2006, what is the difference between the Number of enrolments of both sexes of Nepal and Number of enrolments of both sexes of United Kingdom?
Make the answer very short. -9.54e+05. In the year 2006, what is the difference between the Number of enrolments of both sexes in Slovak Republic and Number of enrolments of both sexes in Slovenia?
Offer a very short reply. 1.60e+05. In the year 2006, what is the difference between the Number of enrolments of both sexes in Slovak Republic and Number of enrolments of both sexes in United Kingdom?
Provide a short and direct response. -7.56e+05. In the year 2006, what is the difference between the Number of enrolments of both sexes of Slovenia and Number of enrolments of both sexes of United Kingdom?
Your answer should be very brief. -9.16e+05. In the year 2007, what is the difference between the Number of enrolments of both sexes of Nepal and Number of enrolments of both sexes of Slovak Republic?
Provide a short and direct response. -1.96e+05. In the year 2007, what is the difference between the Number of enrolments of both sexes in Nepal and Number of enrolments of both sexes in Slovenia?
Provide a short and direct response. -3.82e+04. In the year 2007, what is the difference between the Number of enrolments of both sexes in Nepal and Number of enrolments of both sexes in United Kingdom?
Offer a very short reply. -9.71e+05. In the year 2007, what is the difference between the Number of enrolments of both sexes of Slovak Republic and Number of enrolments of both sexes of Slovenia?
Offer a very short reply. 1.58e+05. In the year 2007, what is the difference between the Number of enrolments of both sexes in Slovak Republic and Number of enrolments of both sexes in United Kingdom?
Your answer should be compact. -7.74e+05. In the year 2007, what is the difference between the Number of enrolments of both sexes in Slovenia and Number of enrolments of both sexes in United Kingdom?
Your answer should be compact. -9.32e+05. What is the ratio of the Number of enrolments of both sexes of Nepal in 2000 to that in 2001?
Provide a short and direct response. 0.89. What is the ratio of the Number of enrolments of both sexes of Slovak Republic in 2000 to that in 2001?
Ensure brevity in your answer.  1. What is the ratio of the Number of enrolments of both sexes of Slovenia in 2000 to that in 2001?
Your answer should be compact. 0.94. What is the ratio of the Number of enrolments of both sexes of United Kingdom in 2000 to that in 2001?
Ensure brevity in your answer.  1. What is the ratio of the Number of enrolments of both sexes in Nepal in 2000 to that in 2002?
Make the answer very short. 0.9. What is the ratio of the Number of enrolments of both sexes of Slovak Republic in 2000 to that in 2002?
Provide a succinct answer. 0.98. What is the ratio of the Number of enrolments of both sexes in Slovenia in 2000 to that in 2002?
Your response must be concise. 0.97. What is the ratio of the Number of enrolments of both sexes of United Kingdom in 2000 to that in 2002?
Give a very brief answer. 0.93. What is the ratio of the Number of enrolments of both sexes in Nepal in 2000 to that in 2003?
Your response must be concise. 1.18. What is the ratio of the Number of enrolments of both sexes in Slovak Republic in 2000 to that in 2003?
Give a very brief answer. 0.95. What is the ratio of the Number of enrolments of both sexes of Slovenia in 2000 to that in 2003?
Your response must be concise. 0.97. What is the ratio of the Number of enrolments of both sexes of Nepal in 2000 to that in 2005?
Provide a succinct answer. 0.85. What is the ratio of the Number of enrolments of both sexes in Slovak Republic in 2000 to that in 2005?
Your answer should be very brief. 0.91. What is the ratio of the Number of enrolments of both sexes in Slovenia in 2000 to that in 2005?
Keep it short and to the point. 1.37. What is the ratio of the Number of enrolments of both sexes in United Kingdom in 2000 to that in 2005?
Your response must be concise. 0.79. What is the ratio of the Number of enrolments of both sexes of Nepal in 2000 to that in 2006?
Give a very brief answer. 0.86. What is the ratio of the Number of enrolments of both sexes of Slovak Republic in 2000 to that in 2006?
Offer a very short reply. 0.94. What is the ratio of the Number of enrolments of both sexes of Slovenia in 2000 to that in 2006?
Keep it short and to the point. 1.42. What is the ratio of the Number of enrolments of both sexes in United Kingdom in 2000 to that in 2006?
Provide a succinct answer. 1.08. What is the ratio of the Number of enrolments of both sexes of Slovak Republic in 2000 to that in 2007?
Ensure brevity in your answer.  0.96. What is the ratio of the Number of enrolments of both sexes of Slovenia in 2000 to that in 2007?
Give a very brief answer. 1.49. What is the ratio of the Number of enrolments of both sexes in United Kingdom in 2000 to that in 2007?
Offer a terse response. 1.07. What is the ratio of the Number of enrolments of both sexes in Nepal in 2001 to that in 2002?
Keep it short and to the point. 1.02. What is the ratio of the Number of enrolments of both sexes in Slovak Republic in 2001 to that in 2002?
Keep it short and to the point. 0.98. What is the ratio of the Number of enrolments of both sexes in Slovenia in 2001 to that in 2002?
Offer a terse response. 1.04. What is the ratio of the Number of enrolments of both sexes of United Kingdom in 2001 to that in 2002?
Your answer should be very brief. 0.92. What is the ratio of the Number of enrolments of both sexes of Nepal in 2001 to that in 2003?
Offer a terse response. 1.33. What is the ratio of the Number of enrolments of both sexes in Slovak Republic in 2001 to that in 2003?
Your answer should be compact. 0.94. What is the ratio of the Number of enrolments of both sexes of Slovenia in 2001 to that in 2003?
Offer a terse response. 1.04. What is the ratio of the Number of enrolments of both sexes of United Kingdom in 2001 to that in 2003?
Keep it short and to the point. 0.99. What is the ratio of the Number of enrolments of both sexes in Nepal in 2001 to that in 2005?
Give a very brief answer. 0.97. What is the ratio of the Number of enrolments of both sexes in Slovak Republic in 2001 to that in 2005?
Offer a very short reply. 0.91. What is the ratio of the Number of enrolments of both sexes of Slovenia in 2001 to that in 2005?
Offer a terse response. 1.46. What is the ratio of the Number of enrolments of both sexes of United Kingdom in 2001 to that in 2005?
Ensure brevity in your answer.  0.78. What is the ratio of the Number of enrolments of both sexes in Nepal in 2001 to that in 2006?
Offer a terse response. 0.97. What is the ratio of the Number of enrolments of both sexes of Slovak Republic in 2001 to that in 2006?
Provide a short and direct response. 0.94. What is the ratio of the Number of enrolments of both sexes of Slovenia in 2001 to that in 2006?
Offer a very short reply. 1.52. What is the ratio of the Number of enrolments of both sexes in United Kingdom in 2001 to that in 2006?
Provide a succinct answer. 1.08. What is the ratio of the Number of enrolments of both sexes of Nepal in 2001 to that in 2007?
Ensure brevity in your answer.  1.13. What is the ratio of the Number of enrolments of both sexes of Slovak Republic in 2001 to that in 2007?
Your answer should be very brief. 0.96. What is the ratio of the Number of enrolments of both sexes in Slovenia in 2001 to that in 2007?
Keep it short and to the point. 1.59. What is the ratio of the Number of enrolments of both sexes of United Kingdom in 2001 to that in 2007?
Keep it short and to the point. 1.07. What is the ratio of the Number of enrolments of both sexes in Nepal in 2002 to that in 2003?
Provide a succinct answer. 1.31. What is the ratio of the Number of enrolments of both sexes in Slovak Republic in 2002 to that in 2003?
Offer a terse response. 0.96. What is the ratio of the Number of enrolments of both sexes in United Kingdom in 2002 to that in 2003?
Give a very brief answer. 1.07. What is the ratio of the Number of enrolments of both sexes in Nepal in 2002 to that in 2005?
Provide a short and direct response. 0.95. What is the ratio of the Number of enrolments of both sexes of Slovak Republic in 2002 to that in 2005?
Ensure brevity in your answer.  0.93. What is the ratio of the Number of enrolments of both sexes of Slovenia in 2002 to that in 2005?
Offer a terse response. 1.41. What is the ratio of the Number of enrolments of both sexes of United Kingdom in 2002 to that in 2005?
Provide a succinct answer. 0.85. What is the ratio of the Number of enrolments of both sexes of Nepal in 2002 to that in 2006?
Keep it short and to the point. 0.95. What is the ratio of the Number of enrolments of both sexes in Slovak Republic in 2002 to that in 2006?
Offer a terse response. 0.96. What is the ratio of the Number of enrolments of both sexes of Slovenia in 2002 to that in 2006?
Provide a short and direct response. 1.46. What is the ratio of the Number of enrolments of both sexes in United Kingdom in 2002 to that in 2006?
Your answer should be compact. 1.17. What is the ratio of the Number of enrolments of both sexes in Nepal in 2002 to that in 2007?
Your answer should be very brief. 1.11. What is the ratio of the Number of enrolments of both sexes in Slovak Republic in 2002 to that in 2007?
Your response must be concise. 0.98. What is the ratio of the Number of enrolments of both sexes in Slovenia in 2002 to that in 2007?
Provide a succinct answer. 1.54. What is the ratio of the Number of enrolments of both sexes of United Kingdom in 2002 to that in 2007?
Offer a terse response. 1.16. What is the ratio of the Number of enrolments of both sexes in Nepal in 2003 to that in 2005?
Offer a terse response. 0.73. What is the ratio of the Number of enrolments of both sexes in Slovak Republic in 2003 to that in 2005?
Provide a short and direct response. 0.96. What is the ratio of the Number of enrolments of both sexes of Slovenia in 2003 to that in 2005?
Your response must be concise. 1.4. What is the ratio of the Number of enrolments of both sexes in United Kingdom in 2003 to that in 2005?
Ensure brevity in your answer.  0.79. What is the ratio of the Number of enrolments of both sexes in Nepal in 2003 to that in 2006?
Ensure brevity in your answer.  0.73. What is the ratio of the Number of enrolments of both sexes in Slovenia in 2003 to that in 2006?
Provide a short and direct response. 1.46. What is the ratio of the Number of enrolments of both sexes of United Kingdom in 2003 to that in 2006?
Provide a short and direct response. 1.09. What is the ratio of the Number of enrolments of both sexes of Nepal in 2003 to that in 2007?
Ensure brevity in your answer.  0.85. What is the ratio of the Number of enrolments of both sexes of Slovak Republic in 2003 to that in 2007?
Your answer should be compact. 1.01. What is the ratio of the Number of enrolments of both sexes in Slovenia in 2003 to that in 2007?
Make the answer very short. 1.53. What is the ratio of the Number of enrolments of both sexes in United Kingdom in 2003 to that in 2007?
Provide a short and direct response. 1.08. What is the ratio of the Number of enrolments of both sexes of Nepal in 2005 to that in 2006?
Your answer should be compact. 1. What is the ratio of the Number of enrolments of both sexes of Slovak Republic in 2005 to that in 2006?
Give a very brief answer. 1.03. What is the ratio of the Number of enrolments of both sexes of Slovenia in 2005 to that in 2006?
Keep it short and to the point. 1.04. What is the ratio of the Number of enrolments of both sexes of United Kingdom in 2005 to that in 2006?
Offer a terse response. 1.38. What is the ratio of the Number of enrolments of both sexes of Nepal in 2005 to that in 2007?
Provide a succinct answer. 1.17. What is the ratio of the Number of enrolments of both sexes of Slovak Republic in 2005 to that in 2007?
Ensure brevity in your answer.  1.06. What is the ratio of the Number of enrolments of both sexes of Slovenia in 2005 to that in 2007?
Offer a very short reply. 1.09. What is the ratio of the Number of enrolments of both sexes of United Kingdom in 2005 to that in 2007?
Offer a terse response. 1.36. What is the ratio of the Number of enrolments of both sexes of Nepal in 2006 to that in 2007?
Offer a very short reply. 1.17. What is the ratio of the Number of enrolments of both sexes of Slovak Republic in 2006 to that in 2007?
Offer a terse response. 1.02. What is the ratio of the Number of enrolments of both sexes in Slovenia in 2006 to that in 2007?
Give a very brief answer. 1.05. What is the ratio of the Number of enrolments of both sexes in United Kingdom in 2006 to that in 2007?
Offer a very short reply. 0.99. What is the difference between the highest and the second highest Number of enrolments of both sexes in Nepal?
Your answer should be very brief. 14. What is the difference between the highest and the second highest Number of enrolments of both sexes of Slovak Republic?
Offer a very short reply. 7282. What is the difference between the highest and the second highest Number of enrolments of both sexes of Slovenia?
Offer a very short reply. 3223. What is the difference between the highest and the second highest Number of enrolments of both sexes of United Kingdom?
Offer a terse response. 2.02e+05. What is the difference between the highest and the lowest Number of enrolments of both sexes of Nepal?
Provide a short and direct response. 5894. What is the difference between the highest and the lowest Number of enrolments of both sexes in Slovak Republic?
Offer a very short reply. 2.12e+04. What is the difference between the highest and the lowest Number of enrolments of both sexes in Slovenia?
Ensure brevity in your answer.  3.37e+04. What is the difference between the highest and the lowest Number of enrolments of both sexes in United Kingdom?
Offer a terse response. 3.70e+05. 